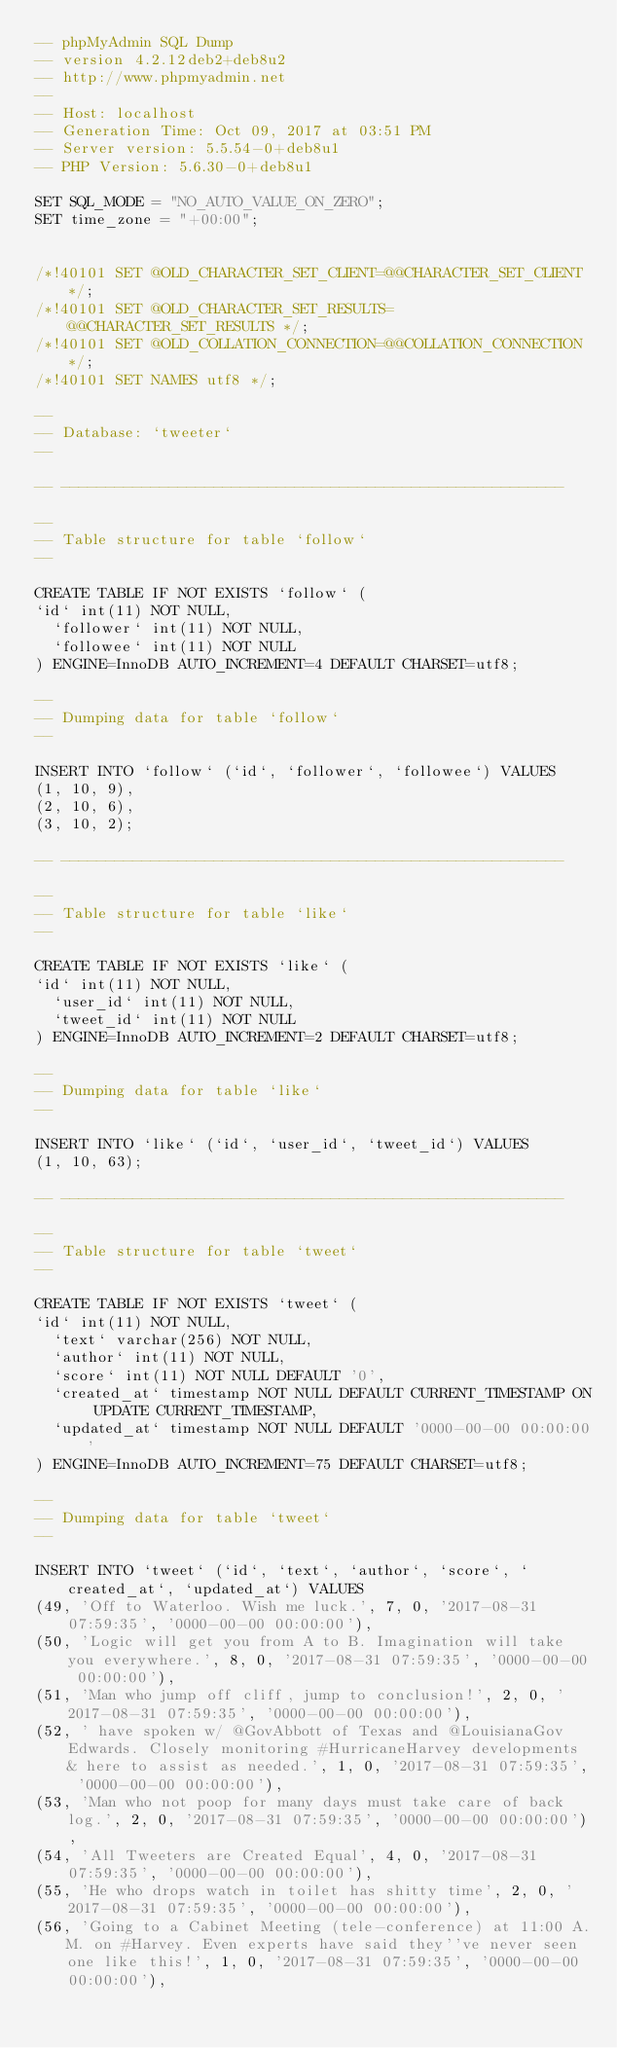<code> <loc_0><loc_0><loc_500><loc_500><_SQL_>-- phpMyAdmin SQL Dump
-- version 4.2.12deb2+deb8u2
-- http://www.phpmyadmin.net
--
-- Host: localhost
-- Generation Time: Oct 09, 2017 at 03:51 PM
-- Server version: 5.5.54-0+deb8u1
-- PHP Version: 5.6.30-0+deb8u1

SET SQL_MODE = "NO_AUTO_VALUE_ON_ZERO";
SET time_zone = "+00:00";


/*!40101 SET @OLD_CHARACTER_SET_CLIENT=@@CHARACTER_SET_CLIENT */;
/*!40101 SET @OLD_CHARACTER_SET_RESULTS=@@CHARACTER_SET_RESULTS */;
/*!40101 SET @OLD_COLLATION_CONNECTION=@@COLLATION_CONNECTION */;
/*!40101 SET NAMES utf8 */;

--
-- Database: `tweeter`
--

-- --------------------------------------------------------

--
-- Table structure for table `follow`
--

CREATE TABLE IF NOT EXISTS `follow` (
`id` int(11) NOT NULL,
  `follower` int(11) NOT NULL,
  `followee` int(11) NOT NULL
) ENGINE=InnoDB AUTO_INCREMENT=4 DEFAULT CHARSET=utf8;

--
-- Dumping data for table `follow`
--

INSERT INTO `follow` (`id`, `follower`, `followee`) VALUES
(1, 10, 9),
(2, 10, 6),
(3, 10, 2);

-- --------------------------------------------------------

--
-- Table structure for table `like`
--

CREATE TABLE IF NOT EXISTS `like` (
`id` int(11) NOT NULL,
  `user_id` int(11) NOT NULL,
  `tweet_id` int(11) NOT NULL
) ENGINE=InnoDB AUTO_INCREMENT=2 DEFAULT CHARSET=utf8;

--
-- Dumping data for table `like`
--

INSERT INTO `like` (`id`, `user_id`, `tweet_id`) VALUES
(1, 10, 63);

-- --------------------------------------------------------

--
-- Table structure for table `tweet`
--

CREATE TABLE IF NOT EXISTS `tweet` (
`id` int(11) NOT NULL,
  `text` varchar(256) NOT NULL,
  `author` int(11) NOT NULL,
  `score` int(11) NOT NULL DEFAULT '0',
  `created_at` timestamp NOT NULL DEFAULT CURRENT_TIMESTAMP ON UPDATE CURRENT_TIMESTAMP,
  `updated_at` timestamp NOT NULL DEFAULT '0000-00-00 00:00:00'
) ENGINE=InnoDB AUTO_INCREMENT=75 DEFAULT CHARSET=utf8;

--
-- Dumping data for table `tweet`
--

INSERT INTO `tweet` (`id`, `text`, `author`, `score`, `created_at`, `updated_at`) VALUES
(49, 'Off to Waterloo. Wish me luck.', 7, 0, '2017-08-31 07:59:35', '0000-00-00 00:00:00'),
(50, 'Logic will get you from A to B. Imagination will take you everywhere.', 8, 0, '2017-08-31 07:59:35', '0000-00-00 00:00:00'),
(51, 'Man who jump off cliff, jump to conclusion!', 2, 0, '2017-08-31 07:59:35', '0000-00-00 00:00:00'),
(52, ' have spoken w/ @GovAbbott of Texas and @LouisianaGov Edwards. Closely monitoring #HurricaneHarvey developments & here to assist as needed.', 1, 0, '2017-08-31 07:59:35', '0000-00-00 00:00:00'),
(53, 'Man who not poop for many days must take care of back log.', 2, 0, '2017-08-31 07:59:35', '0000-00-00 00:00:00'),
(54, 'All Tweeters are Created Equal', 4, 0, '2017-08-31 07:59:35', '0000-00-00 00:00:00'),
(55, 'He who drops watch in toilet has shitty time', 2, 0, '2017-08-31 07:59:35', '0000-00-00 00:00:00'),
(56, 'Going to a Cabinet Meeting (tele-conference) at 11:00 A.M. on #Harvey. Even experts have said they''ve never seen one like this!', 1, 0, '2017-08-31 07:59:35', '0000-00-00 00:00:00'),</code> 